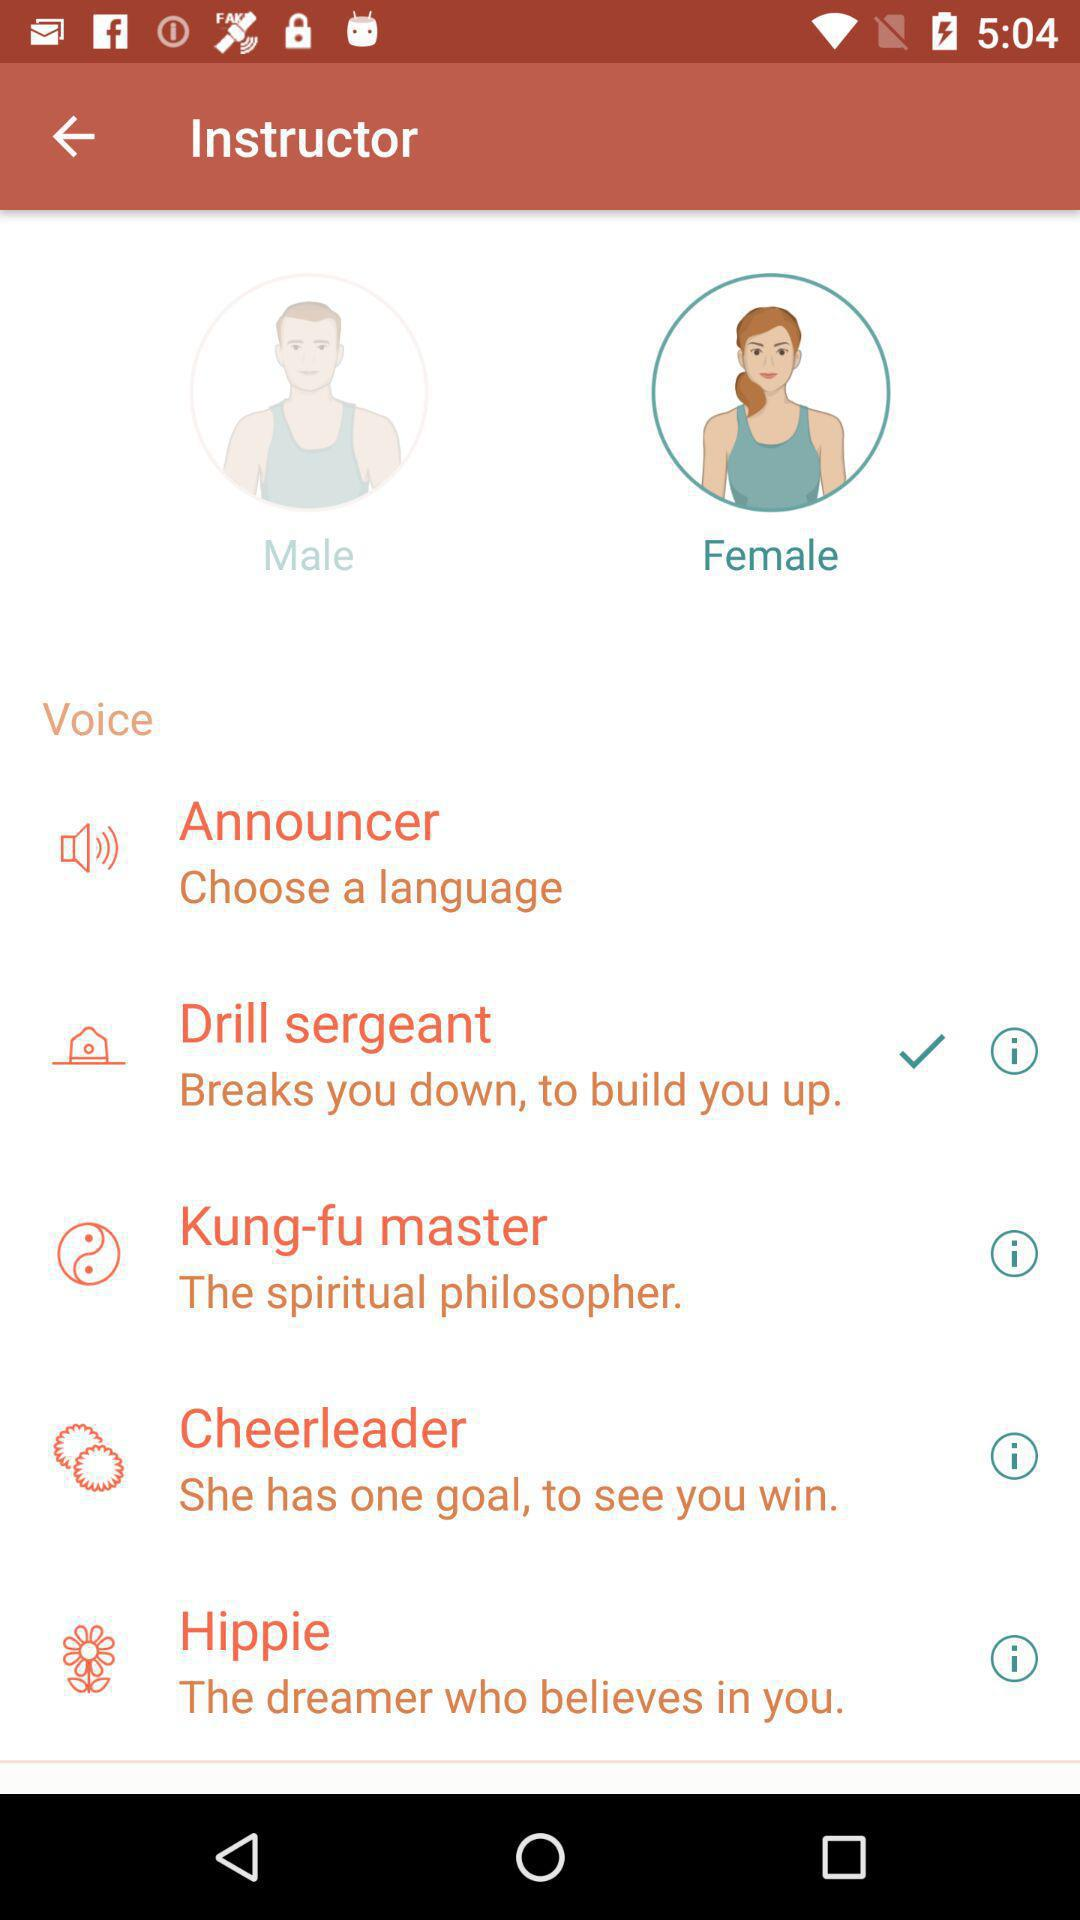What is the gender of the selected instructor? The gender of the selected instructor is female. 